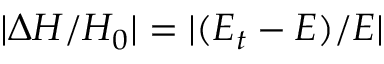Convert formula to latex. <formula><loc_0><loc_0><loc_500><loc_500>| \Delta H / H _ { 0 } | = | ( E _ { t } - E ) / E |</formula> 